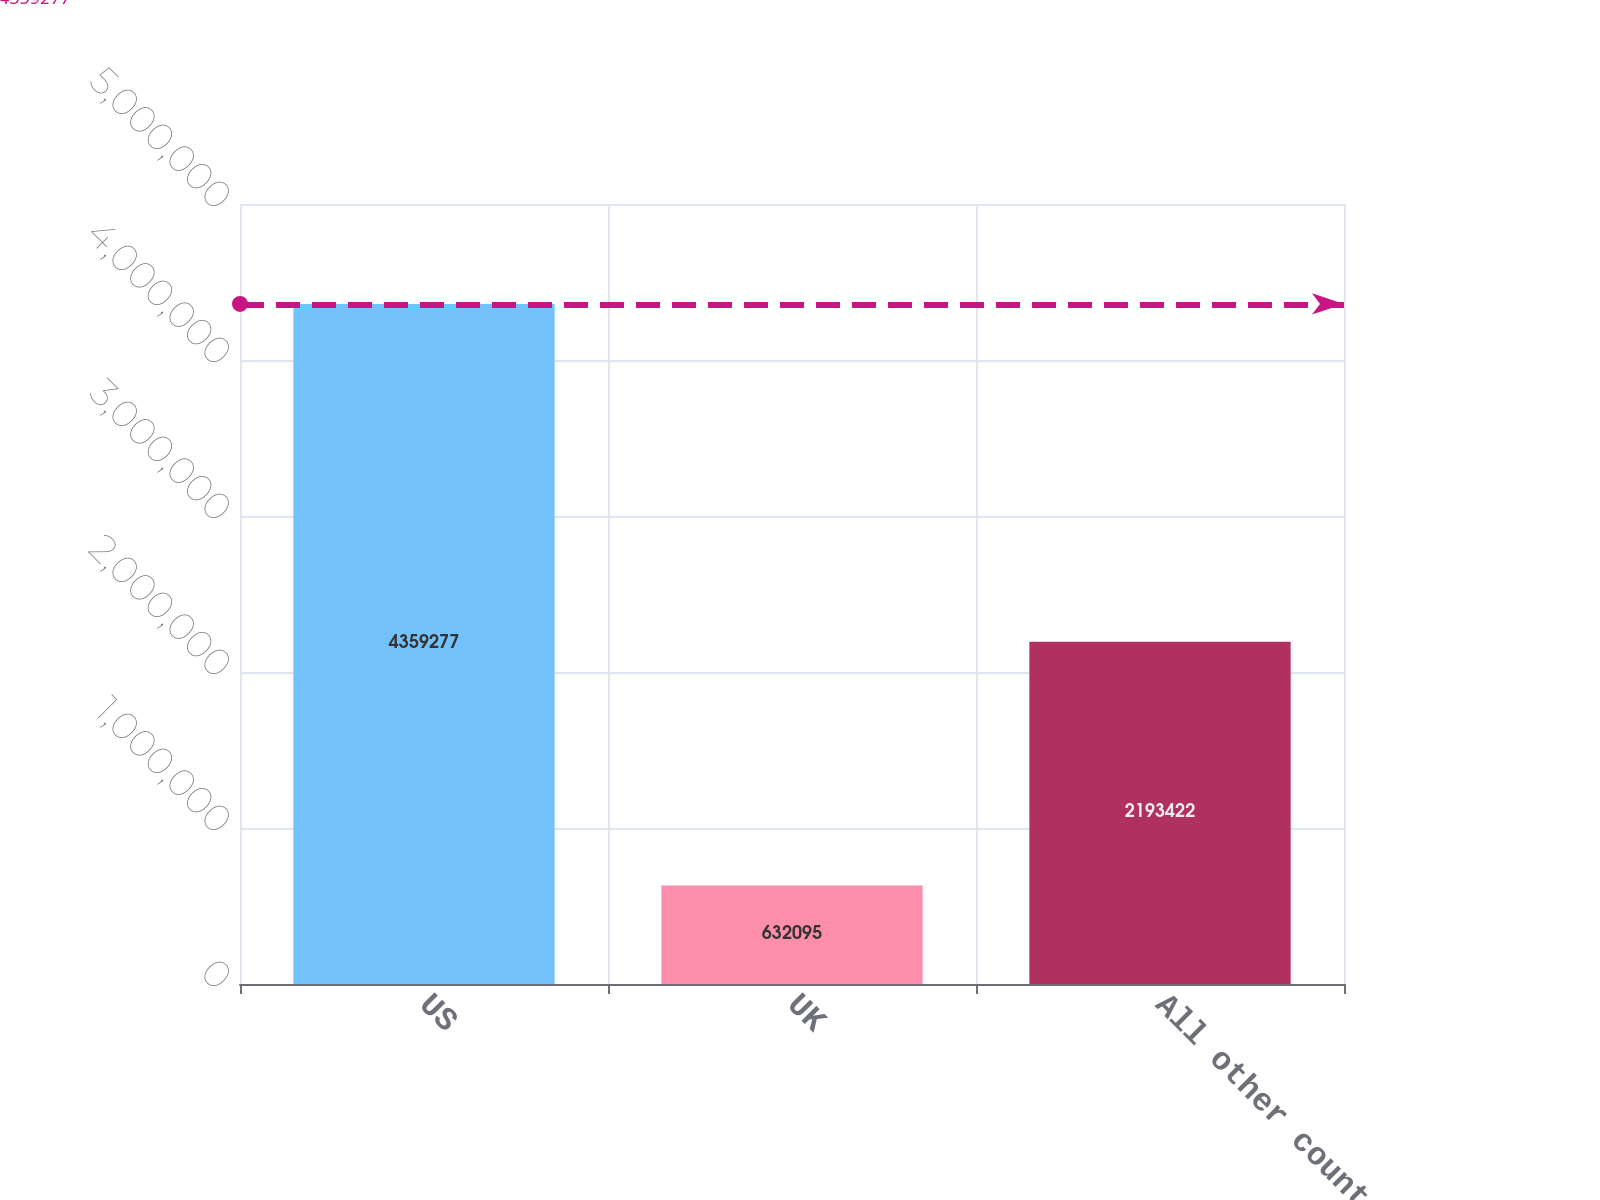<chart> <loc_0><loc_0><loc_500><loc_500><bar_chart><fcel>US<fcel>UK<fcel>All other countries<nl><fcel>4.35928e+06<fcel>632095<fcel>2.19342e+06<nl></chart> 